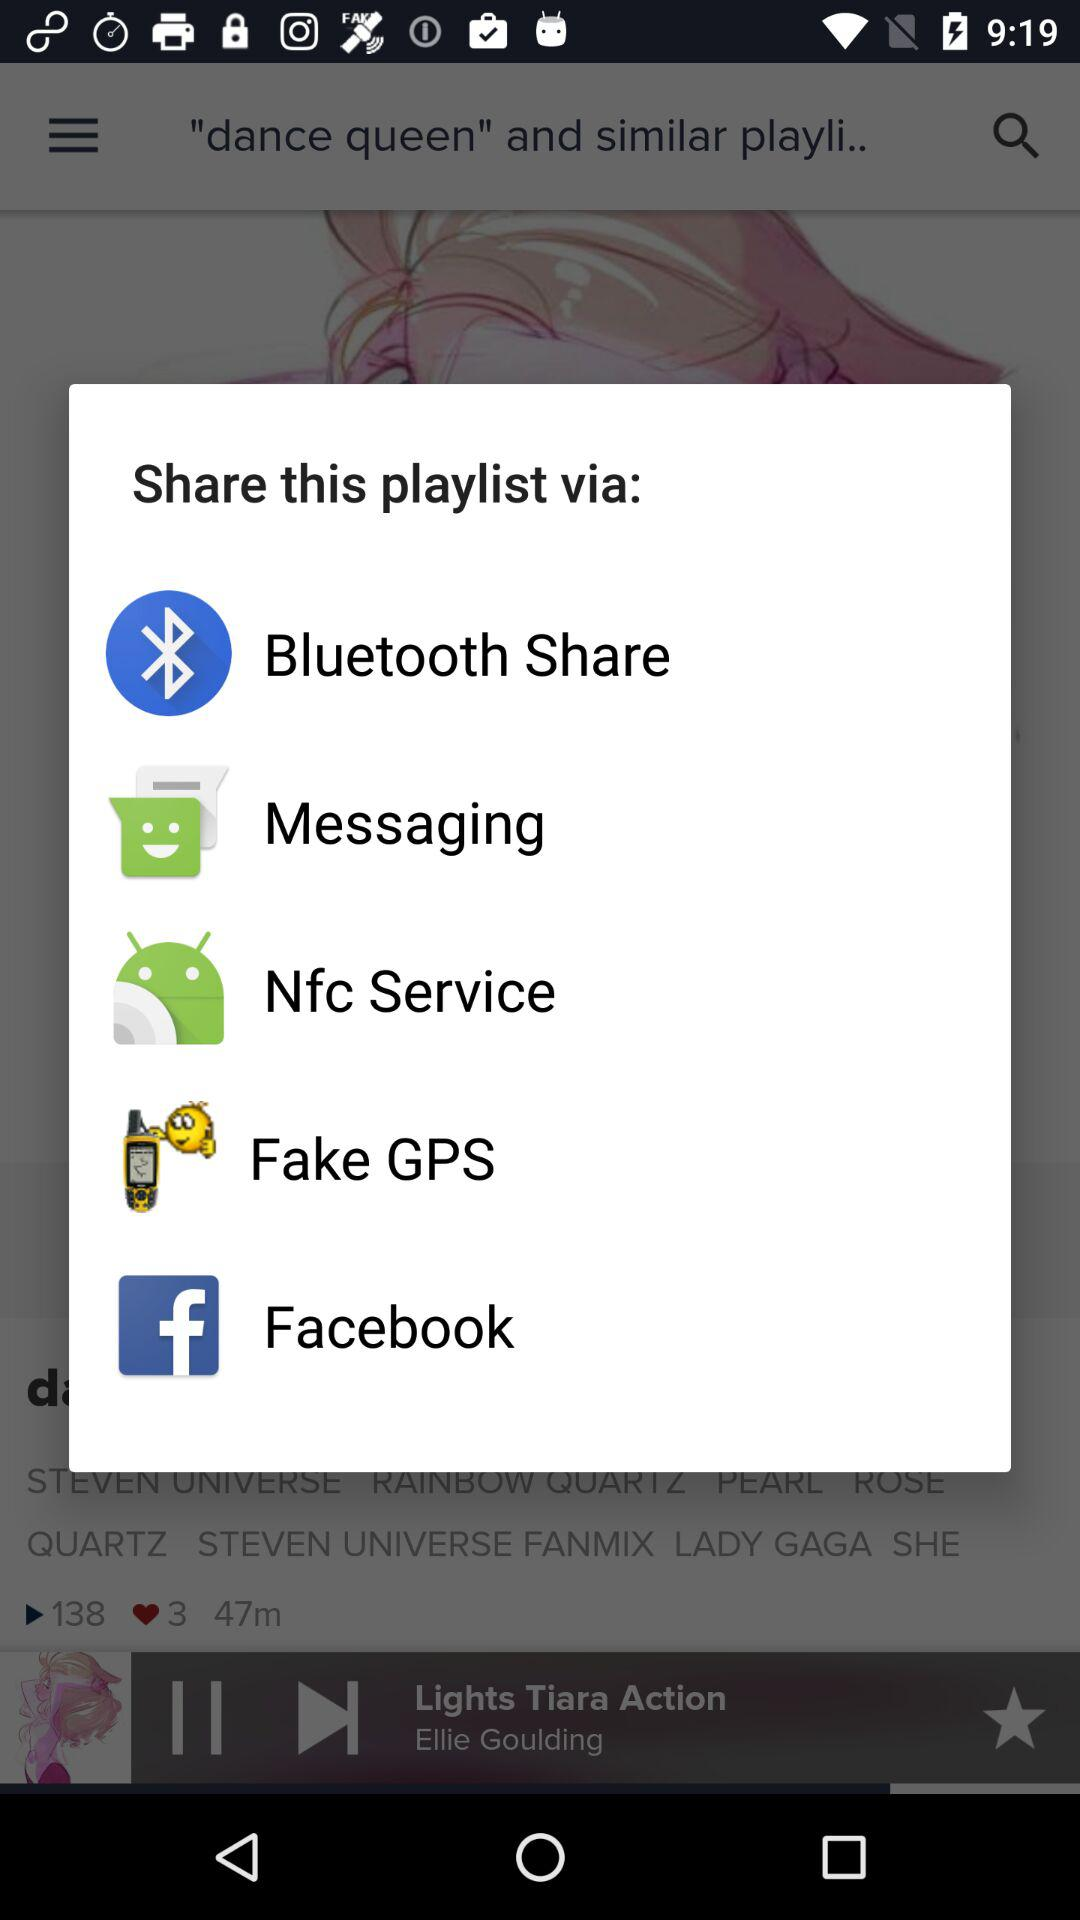What is the singer name of the current playing song? The singer name is Ellie Goulding. 